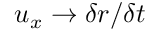<formula> <loc_0><loc_0><loc_500><loc_500>u _ { x } \rightarrow \delta r / \delta t</formula> 